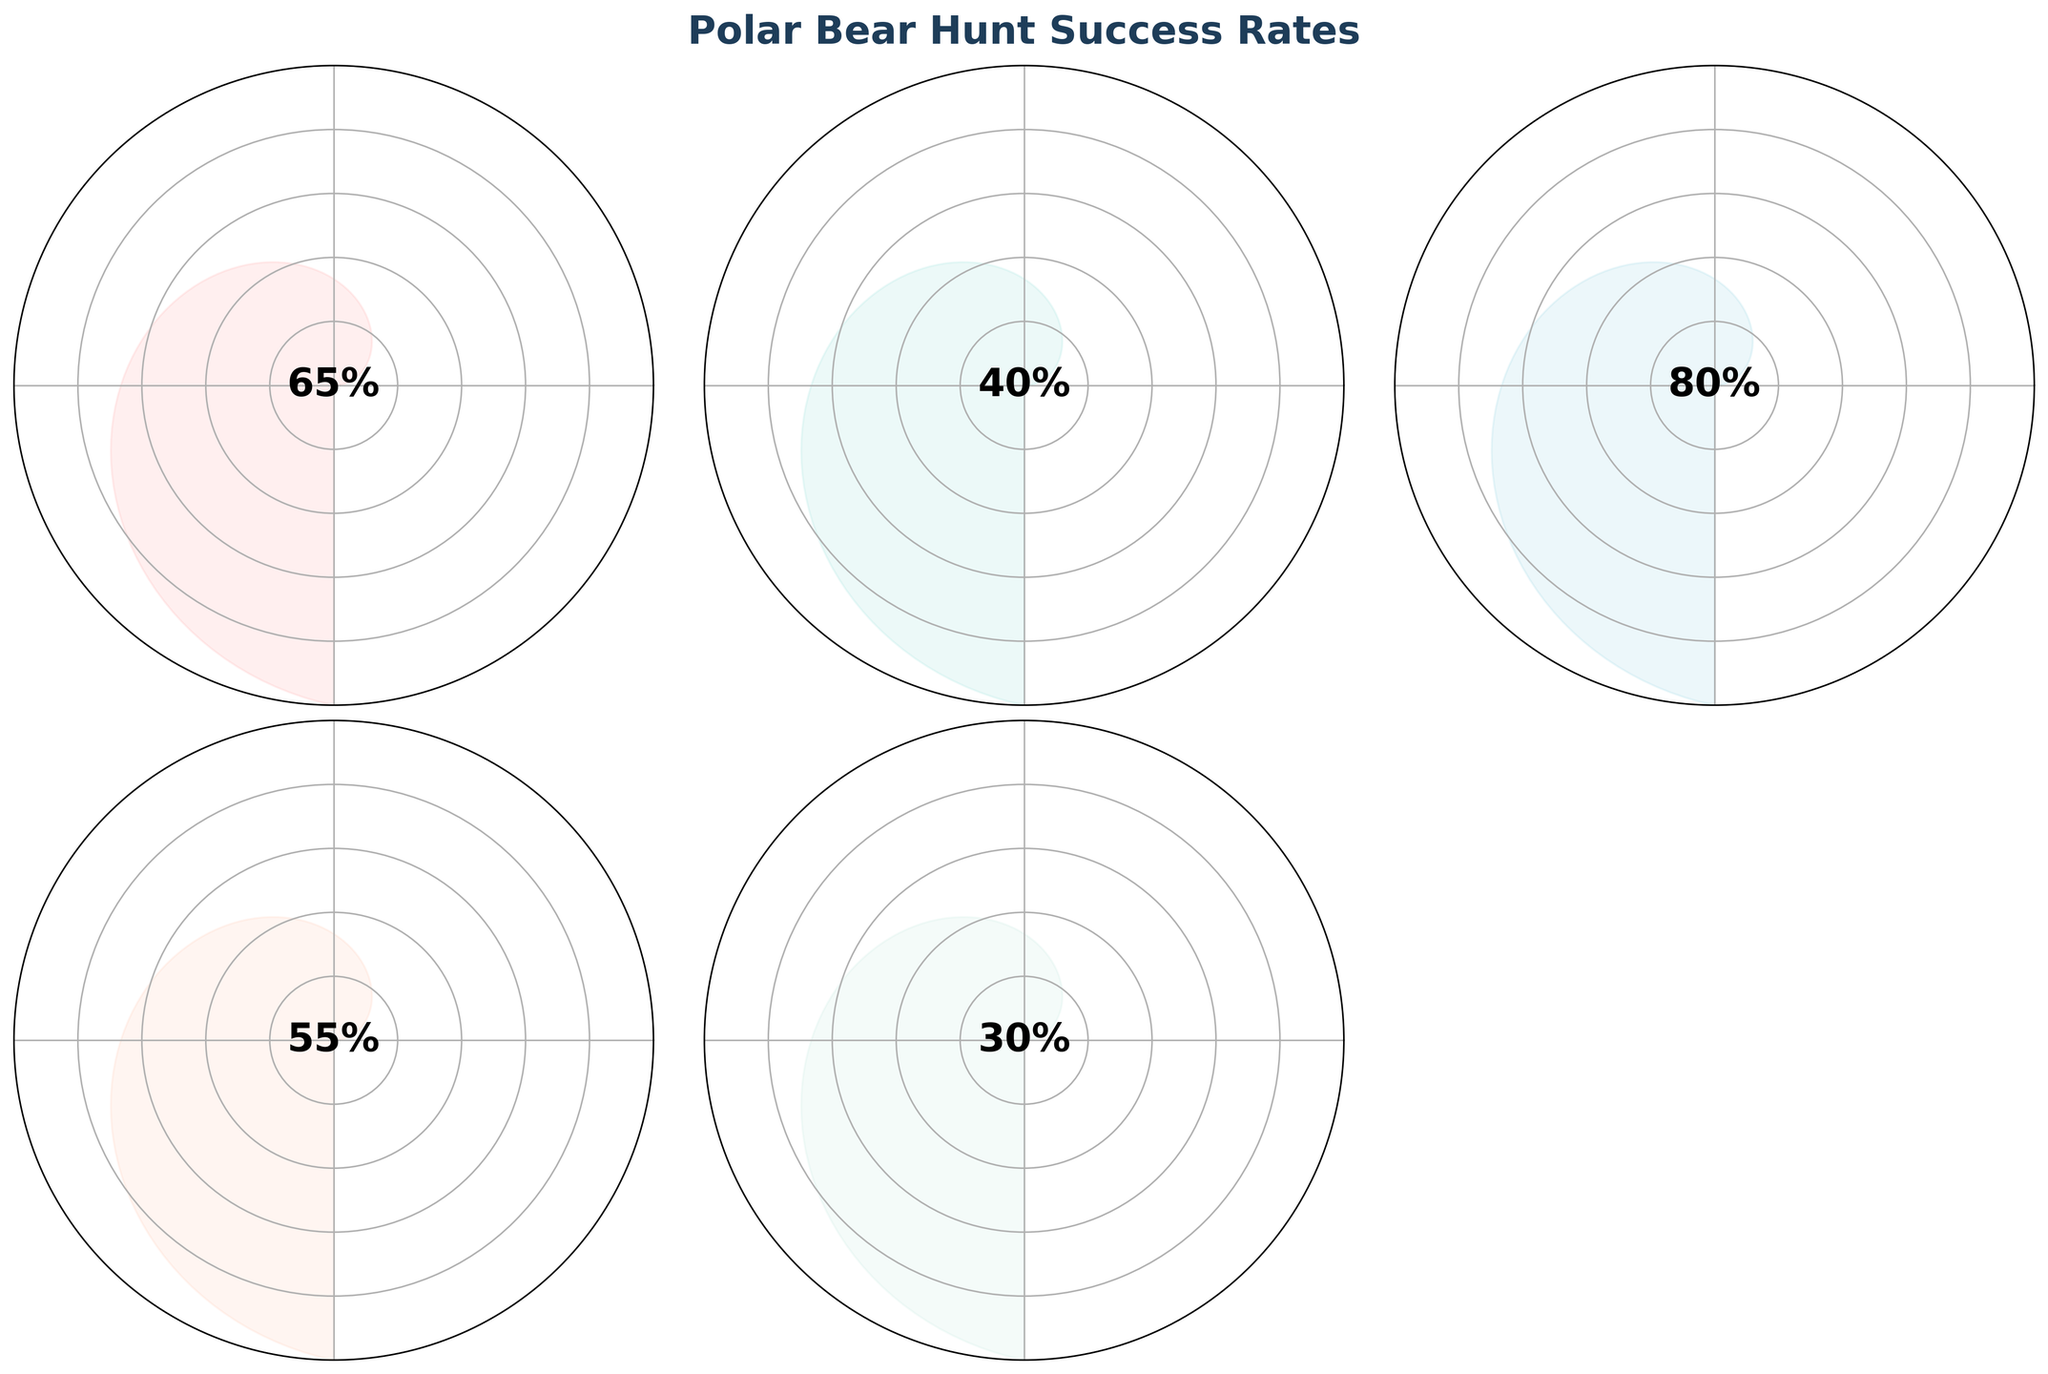what is the highest success rate on the gauge charts? Looking at the gauge charts, the highest percentage displayed in the central text is 80%. The hunt type associated with this rate is Fish Hunt.
Answer: 80% which hunt type has the lowest success rate? Observing the gauge charts, Caribou Hunt shows the lowest success rate with a percentage of 30%.
Answer: Caribou Hunt how many gauge charts have a success rate above 60%? The gauge charts for Seal Hunt (65%), Fish Hunt (80%), and Bird Hunt (55%) are the relevant rates to be examined. Only Seal Hunt and Fish Hunt exceed 60%. Therefore, there are 2 charts with rates above 60%.
Answer: 2 calculate the average success rate of all hunt types? The success rates are 65%, 40%, 80%, 55%, and 30%. Summing them gives 270%, and dividing by 5 (number of hunt types) gives 54%.
Answer: 54% compare the success rate of Bird Hunt to Beluga Whale Hunt. Which one is higher and by how much? Bird Hunt's success rate is 55%, and Beluga Whale Hunt's rate is 40%. Subtracting 40% from 55% gives 15%. Thus, Bird Hunt's rate is higher by 15%.
Answer: Bird Hunt by 15% which hunt type is nearest to having a 50% success rate on the figure? Inspecting the percentages, we see that Bird Hunt with 55% is the closest to 50%.
Answer: Bird Hunt what is the total combined success rate of the Seal Hunt and Fish Hunt? The success rates for Seal Hunt and Fish Hunt are 65% and 80%, respectively. Adding these gives 145%.
Answer: 145% compare how far the success rate of Caribou Hunt is from the highest rate shown? The highest success rate is 80% (Fish Hunt), and Caribou Hunt has 30%. Subtracting 30% from 80% gives 50%. Therefore, Caribou Hunt is 50% away from the highest rate.
Answer: 50% if a polar bear had the choice of only two hunt types with success rates above 50%, which ones would they be? The hunt types with success rates above 50% are Seal Hunt (65%) and Fish Hunt (80%). These are the two options that would be the best choice for the polar bear.
Answer: Seal Hunt and Fish Hunt 